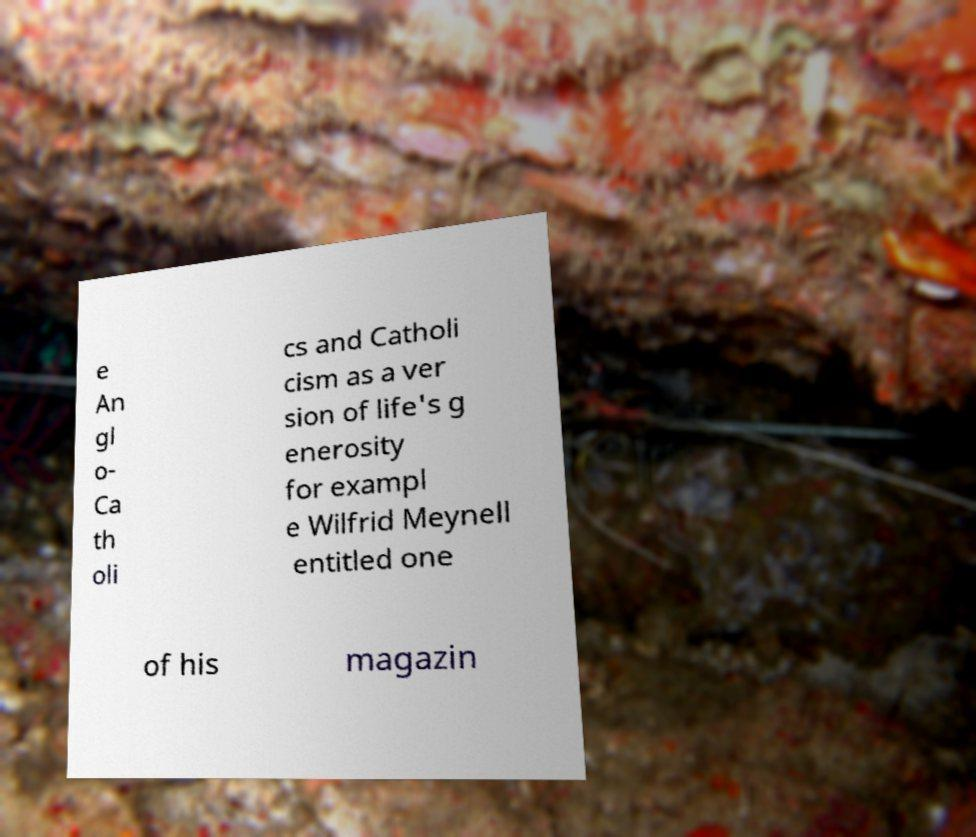For documentation purposes, I need the text within this image transcribed. Could you provide that? e An gl o- Ca th oli cs and Catholi cism as a ver sion of life's g enerosity for exampl e Wilfrid Meynell entitled one of his magazin 